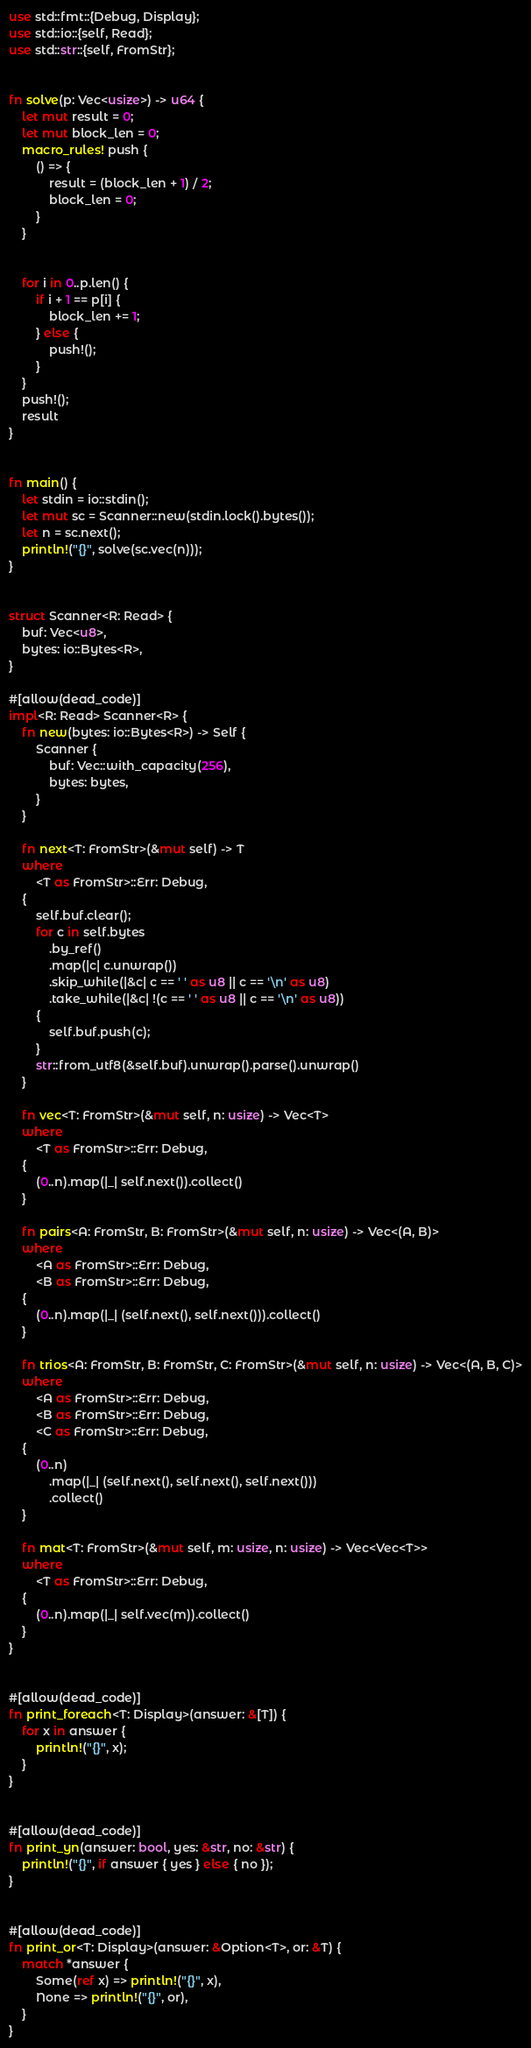Convert code to text. <code><loc_0><loc_0><loc_500><loc_500><_Rust_>use std::fmt::{Debug, Display};
use std::io::{self, Read};
use std::str::{self, FromStr};


fn solve(p: Vec<usize>) -> u64 {
    let mut result = 0;
    let mut block_len = 0;
    macro_rules! push {
        () => {
            result = (block_len + 1) / 2;
            block_len = 0;
        }
    }


    for i in 0..p.len() {
        if i + 1 == p[i] {
            block_len += 1;
        } else {
            push!();
        }
    }
    push!();
    result
}


fn main() {
    let stdin = io::stdin();
    let mut sc = Scanner::new(stdin.lock().bytes());
    let n = sc.next();
    println!("{}", solve(sc.vec(n)));
}


struct Scanner<R: Read> {
    buf: Vec<u8>,
    bytes: io::Bytes<R>,
}

#[allow(dead_code)]
impl<R: Read> Scanner<R> {
    fn new(bytes: io::Bytes<R>) -> Self {
        Scanner {
            buf: Vec::with_capacity(256),
            bytes: bytes,
        }
    }

    fn next<T: FromStr>(&mut self) -> T
    where
        <T as FromStr>::Err: Debug,
    {
        self.buf.clear();
        for c in self.bytes
            .by_ref()
            .map(|c| c.unwrap())
            .skip_while(|&c| c == ' ' as u8 || c == '\n' as u8)
            .take_while(|&c| !(c == ' ' as u8 || c == '\n' as u8))
        {
            self.buf.push(c);
        }
        str::from_utf8(&self.buf).unwrap().parse().unwrap()
    }

    fn vec<T: FromStr>(&mut self, n: usize) -> Vec<T>
    where
        <T as FromStr>::Err: Debug,
    {
        (0..n).map(|_| self.next()).collect()
    }

    fn pairs<A: FromStr, B: FromStr>(&mut self, n: usize) -> Vec<(A, B)>
    where
        <A as FromStr>::Err: Debug,
        <B as FromStr>::Err: Debug,
    {
        (0..n).map(|_| (self.next(), self.next())).collect()
    }

    fn trios<A: FromStr, B: FromStr, C: FromStr>(&mut self, n: usize) -> Vec<(A, B, C)>
    where
        <A as FromStr>::Err: Debug,
        <B as FromStr>::Err: Debug,
        <C as FromStr>::Err: Debug,
    {
        (0..n)
            .map(|_| (self.next(), self.next(), self.next()))
            .collect()
    }

    fn mat<T: FromStr>(&mut self, m: usize, n: usize) -> Vec<Vec<T>>
    where
        <T as FromStr>::Err: Debug,
    {
        (0..n).map(|_| self.vec(m)).collect()
    }
}


#[allow(dead_code)]
fn print_foreach<T: Display>(answer: &[T]) {
    for x in answer {
        println!("{}", x);
    }
}


#[allow(dead_code)]
fn print_yn(answer: bool, yes: &str, no: &str) {
    println!("{}", if answer { yes } else { no });
}


#[allow(dead_code)]
fn print_or<T: Display>(answer: &Option<T>, or: &T) {
    match *answer {
        Some(ref x) => println!("{}", x),
        None => println!("{}", or),
    }
}
</code> 